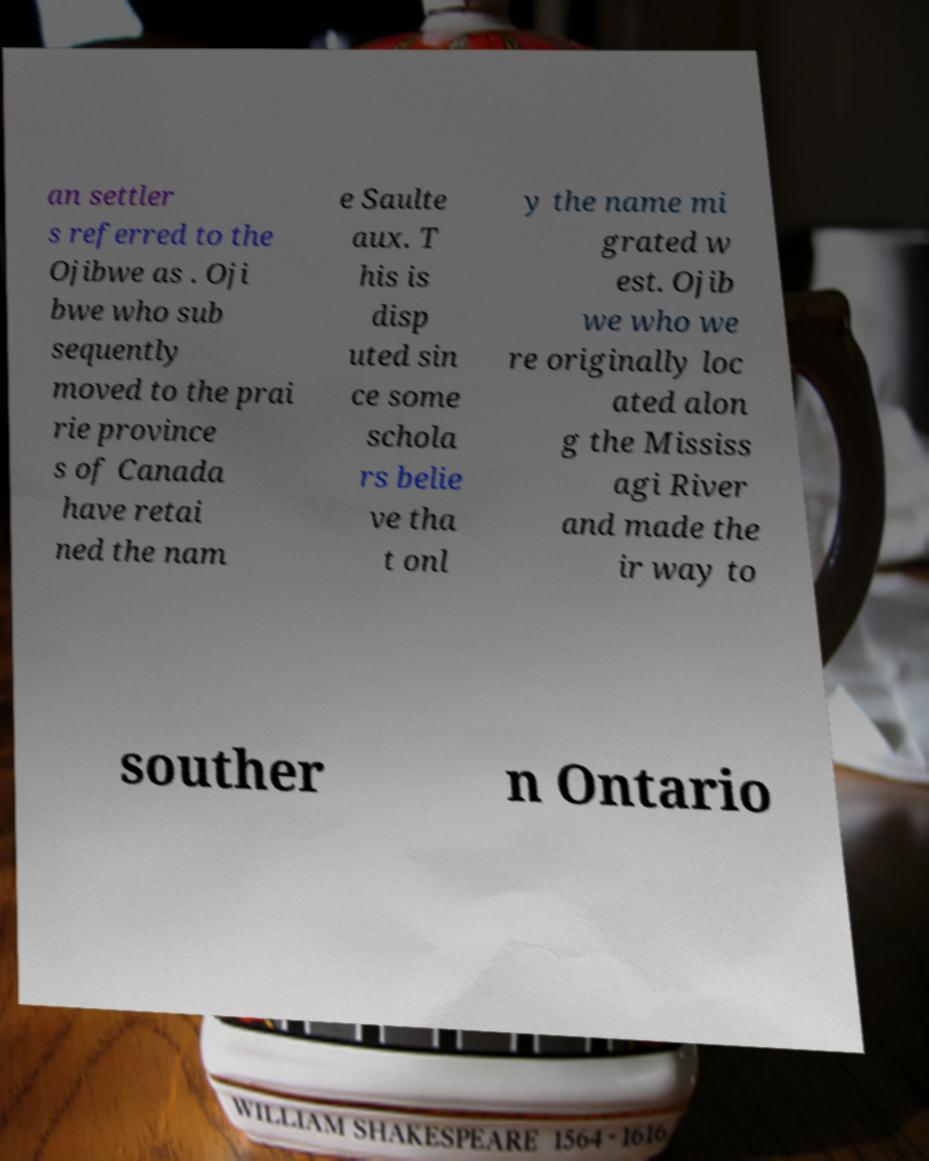Can you accurately transcribe the text from the provided image for me? an settler s referred to the Ojibwe as . Oji bwe who sub sequently moved to the prai rie province s of Canada have retai ned the nam e Saulte aux. T his is disp uted sin ce some schola rs belie ve tha t onl y the name mi grated w est. Ojib we who we re originally loc ated alon g the Mississ agi River and made the ir way to souther n Ontario 